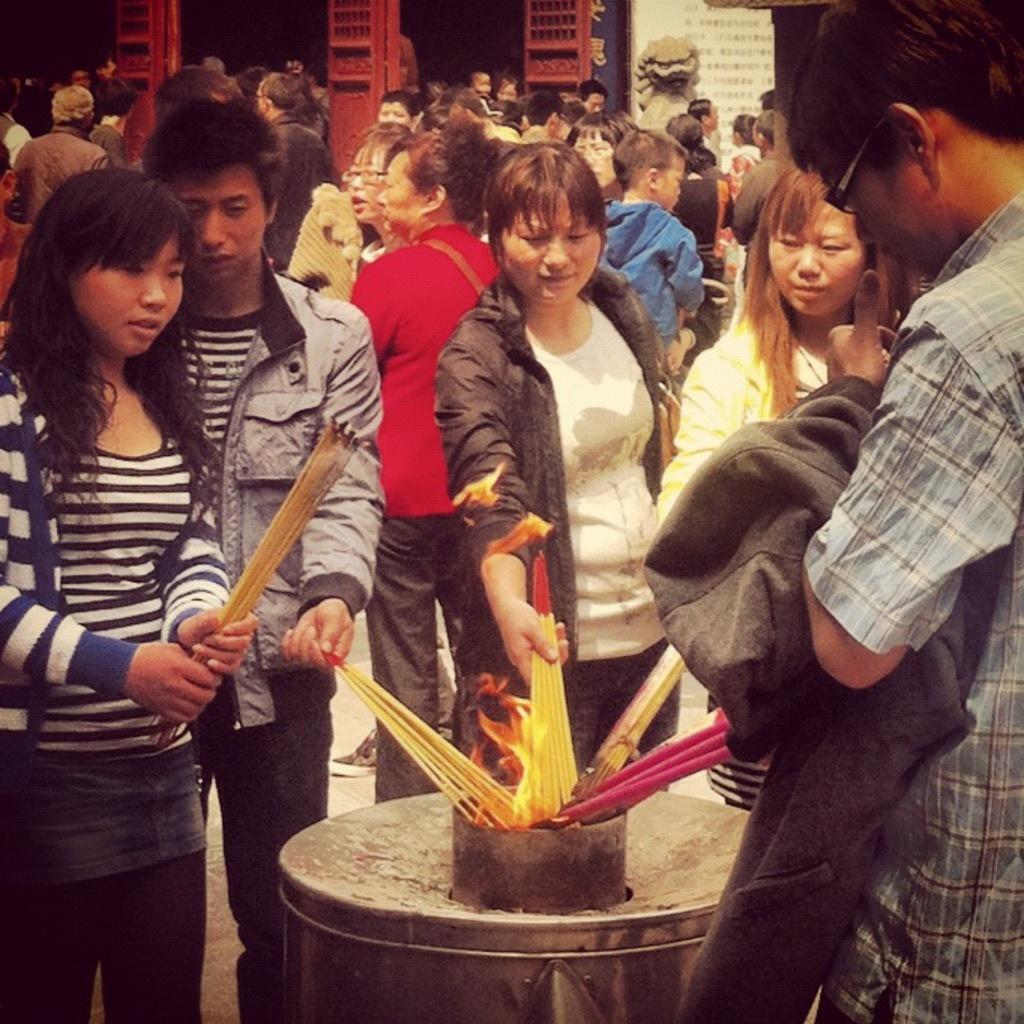Describe this image in one or two sentences. In the foreground of the picture there are people holding incense sticks and trying to fire them. In the center there is flame. In the background there are people, doors, sculpture, wall and other objects. 